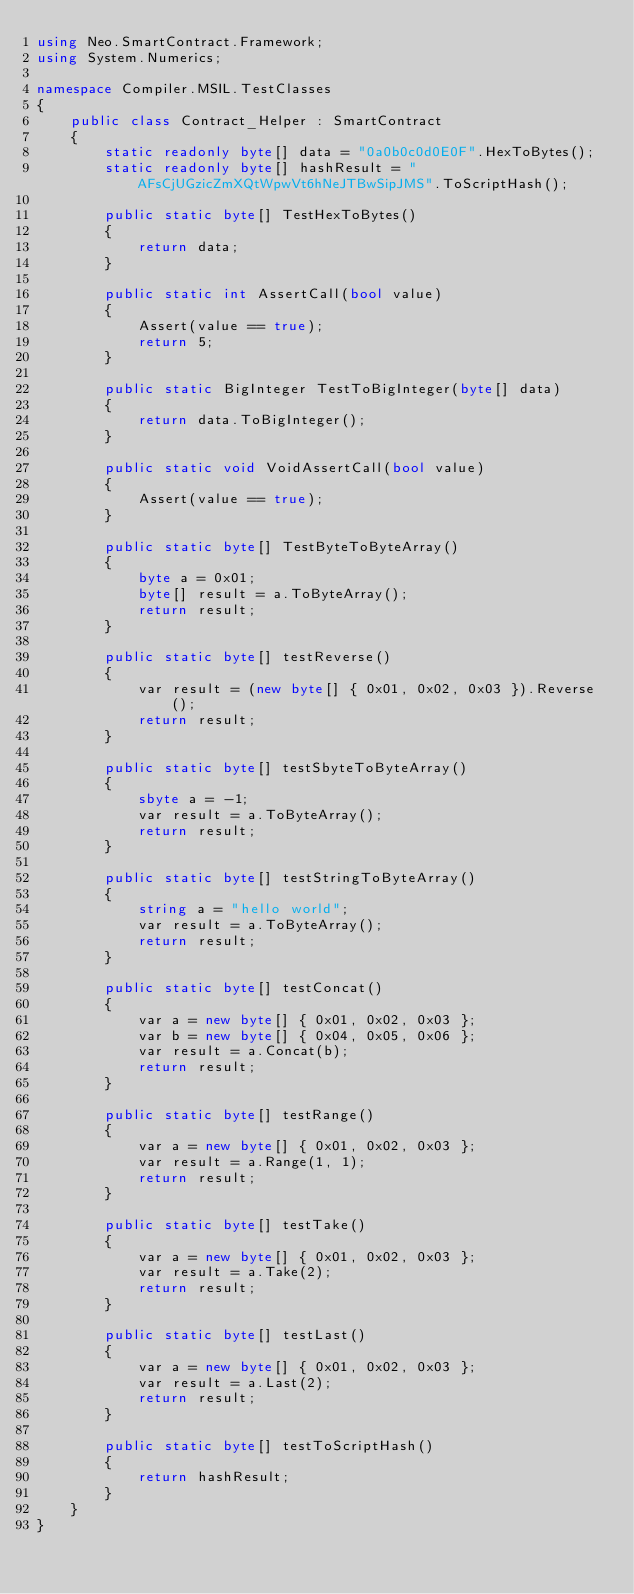Convert code to text. <code><loc_0><loc_0><loc_500><loc_500><_C#_>using Neo.SmartContract.Framework;
using System.Numerics;

namespace Compiler.MSIL.TestClasses
{
    public class Contract_Helper : SmartContract
    {
        static readonly byte[] data = "0a0b0c0d0E0F".HexToBytes();
        static readonly byte[] hashResult = "AFsCjUGzicZmXQtWpwVt6hNeJTBwSipJMS".ToScriptHash();

        public static byte[] TestHexToBytes()
        {
            return data;
        }

        public static int AssertCall(bool value)
        {
            Assert(value == true);
            return 5;
        }

        public static BigInteger TestToBigInteger(byte[] data)
        {
            return data.ToBigInteger();
        }

        public static void VoidAssertCall(bool value)
        {
            Assert(value == true);
        }

        public static byte[] TestByteToByteArray()
        {
            byte a = 0x01;
            byte[] result = a.ToByteArray();
            return result;
        }

        public static byte[] testReverse()
        {
            var result = (new byte[] { 0x01, 0x02, 0x03 }).Reverse();
            return result;
        }

        public static byte[] testSbyteToByteArray()
        {
            sbyte a = -1;
            var result = a.ToByteArray();
            return result;
        }

        public static byte[] testStringToByteArray()
        {
            string a = "hello world";
            var result = a.ToByteArray();
            return result;
        }

        public static byte[] testConcat()
        {
            var a = new byte[] { 0x01, 0x02, 0x03 };
            var b = new byte[] { 0x04, 0x05, 0x06 };
            var result = a.Concat(b);
            return result;
        }

        public static byte[] testRange()
        {
            var a = new byte[] { 0x01, 0x02, 0x03 };
            var result = a.Range(1, 1);
            return result;
        }

        public static byte[] testTake()
        {
            var a = new byte[] { 0x01, 0x02, 0x03 };
            var result = a.Take(2);
            return result;
        }

        public static byte[] testLast()
        {
            var a = new byte[] { 0x01, 0x02, 0x03 };
            var result = a.Last(2);
            return result;
        }

        public static byte[] testToScriptHash()
        {
            return hashResult;
        }
    }
}
</code> 